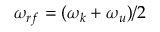<formula> <loc_0><loc_0><loc_500><loc_500>\omega _ { r f } = ( \omega _ { k } + \omega _ { u } ) / 2</formula> 